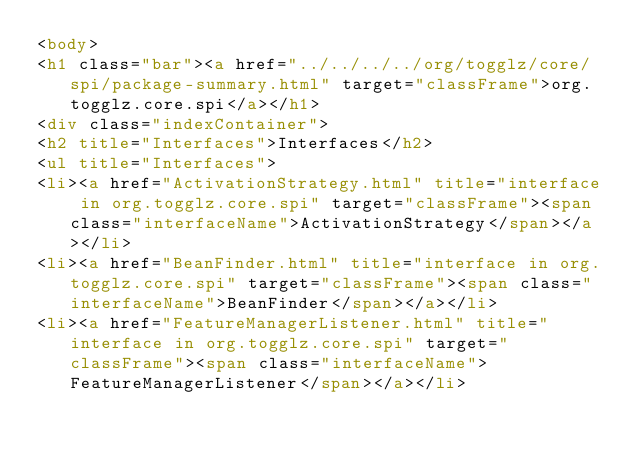<code> <loc_0><loc_0><loc_500><loc_500><_HTML_><body>
<h1 class="bar"><a href="../../../../org/togglz/core/spi/package-summary.html" target="classFrame">org.togglz.core.spi</a></h1>
<div class="indexContainer">
<h2 title="Interfaces">Interfaces</h2>
<ul title="Interfaces">
<li><a href="ActivationStrategy.html" title="interface in org.togglz.core.spi" target="classFrame"><span class="interfaceName">ActivationStrategy</span></a></li>
<li><a href="BeanFinder.html" title="interface in org.togglz.core.spi" target="classFrame"><span class="interfaceName">BeanFinder</span></a></li>
<li><a href="FeatureManagerListener.html" title="interface in org.togglz.core.spi" target="classFrame"><span class="interfaceName">FeatureManagerListener</span></a></li></code> 